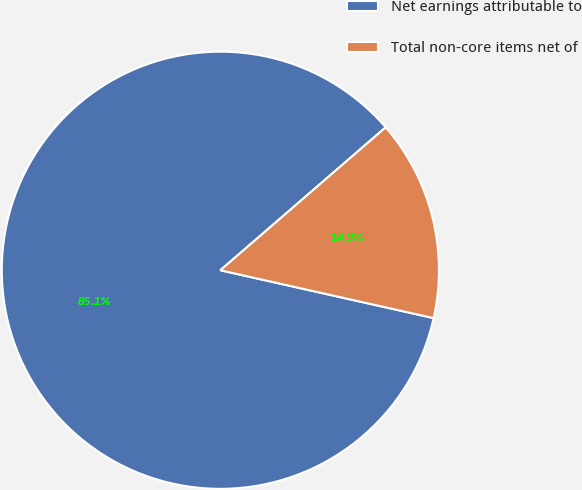<chart> <loc_0><loc_0><loc_500><loc_500><pie_chart><fcel>Net earnings attributable to<fcel>Total non-core items net of<nl><fcel>85.14%<fcel>14.86%<nl></chart> 